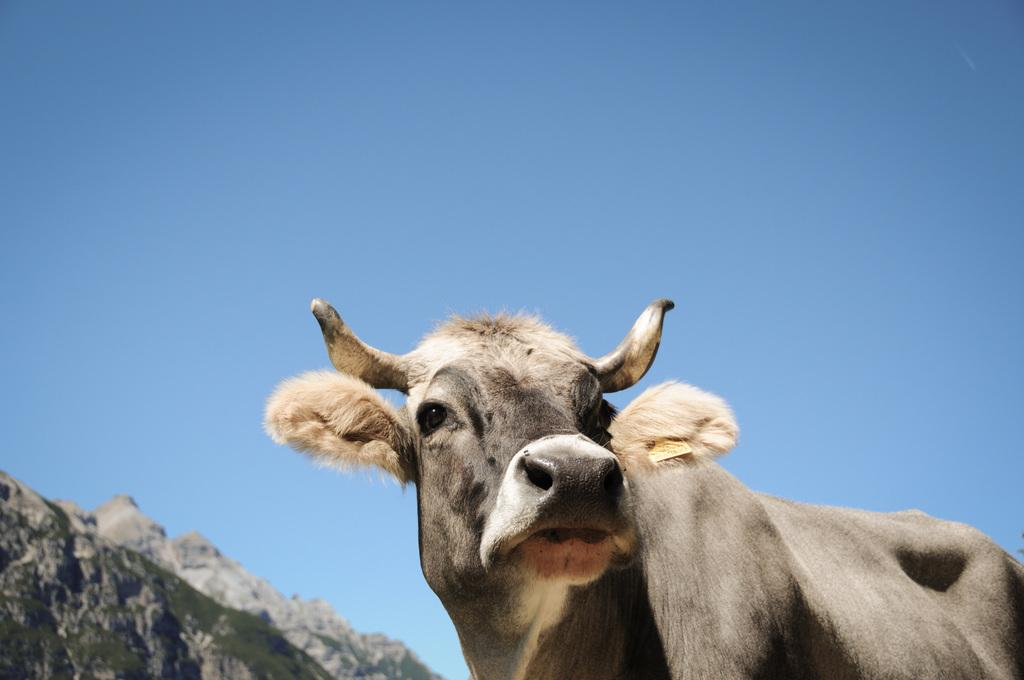What is the color of the sky in the image? The sky in the image is clear and blue. What can be seen on the left side of the image? There are hills visible on the left side of the image. What is the main subject of the image? The image features an animal as the main subject. Is the grandmother reading a book in the image? There is no grandmother or book present in the image. What type of art is displayed on the hills in the image? There is no art displayed on the hills in the image; the hills are a natural landscape. 